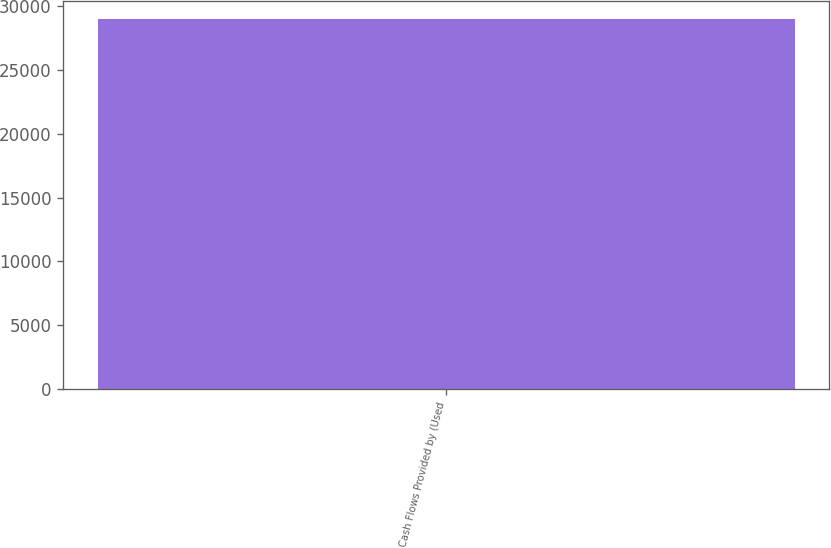<chart> <loc_0><loc_0><loc_500><loc_500><bar_chart><fcel>Cash Flows Provided by (Used<nl><fcel>28958<nl></chart> 